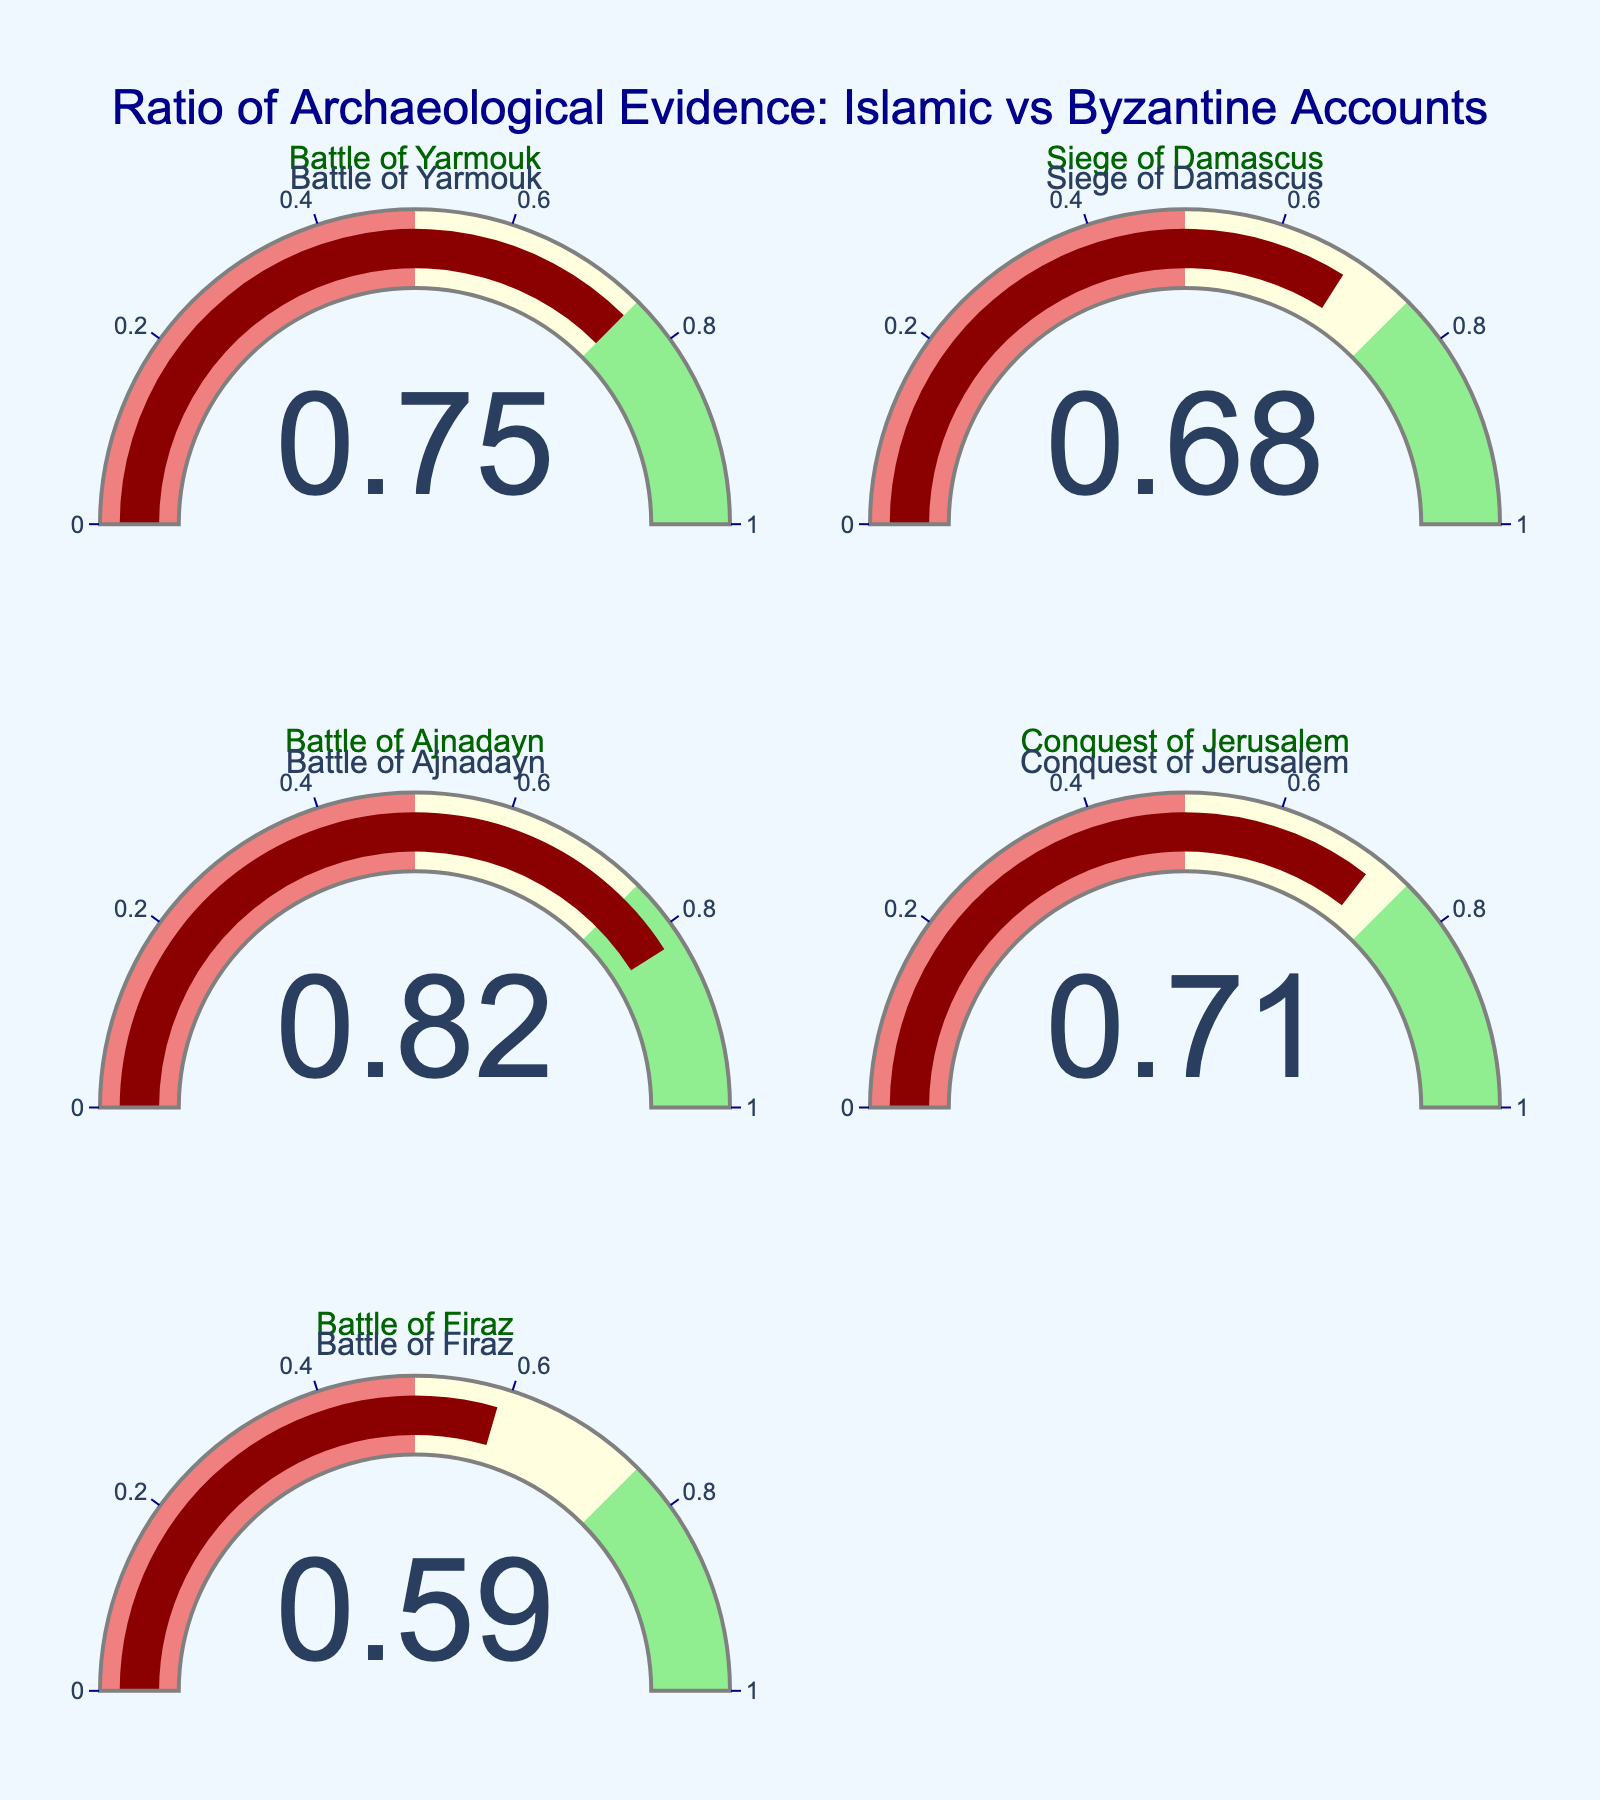What's the ratio of archaeological evidence for the Battle of Yarmouk? The gauge for the Battle of Yarmouk shows the ratio directly.
Answer: 0.75 Which battle has the highest ratio of archaeological evidence supporting Islamic accounts? By comparing the ratios of all battles, the Battle of Ajnadayn has the highest ratio.
Answer: Battle of Ajnadayn What is the average ratio of archaeological evidence for all the battles? Sum up the ratios of all battles and then divide by the number of battles: (0.75 + 0.68 + 0.82 + 0.71 + 0.59) / 5 = 3.55 / 5 = 0.71
Answer: 0.71 Which battle has the lowest ratio of archaeological evidence supporting Islamic accounts? By comparing the ratios of all battles, the Battle of Firaz has the lowest ratio.
Answer: Battle of Firaz How many battles have a ratio higher than 0.7? Count the battles with a ratio higher than 0.7: Battle of Yarmouk, Battle of Ajnadayn, Conquest of Jerusalem.
Answer: 3 What is the difference in the ratio between the Battle of Ajnadayn and the Siege of Damascus? Calculate the difference: 0.82 - 0.68 = 0.14
Answer: 0.14 Are there more battles with a ratio above or below 0.75? Count the battles above 0.75 (Battle of Ajnadayn) and below 0.75 (Siege of Damascus, Conquest of Jerusalem, Battle of Firaz).
Answer: Below Which battle has the closest ratio to 0.7? Compare each ratio to 0.7 and find the closest one: Conquest of Jerusalem with a ratio of 0.71.
Answer: Conquest of Jerusalem How many battles have a ratio between 0.5 and 0.75? Count the battles with a ratio within the range 0.5 to 0.75: Battle of Yarmouk, Siege of Damascus, Conquest of Jerusalem, Battle of Firaz.
Answer: 4 